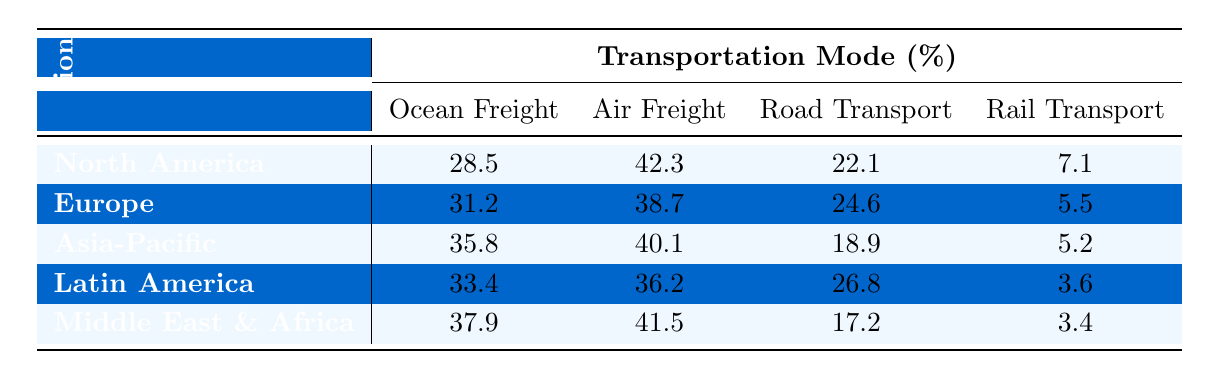What is the highest percentage for Ocean Freight among the regions? By looking at the Ocean Freight percentages for each region, we can see that North America has 28.5, Europe has 31.2, Asia-Pacific has 35.8, Latin America has 33.4, and the Middle East & Africa has 37.9. The highest percentage is 37.9, which is in the Middle East & Africa region.
Answer: 37.9 Which region has the lowest percentage for Road Transport? Checking the Road Transport percentages, North America has 22.1, Europe has 24.6, Asia-Pacific has 18.9, Latin America has 26.8, and the Middle East & Africa has 17.2. The lowest percentage is found in the Middle East & Africa at 17.2.
Answer: 17.2 What is the sum of Air Freight percentages for all regions? Adding the Air Freight percentages from the table gives us: 42.3 (North America) + 38.7 (Europe) + 40.1 (Asia-Pacific) + 36.2 (Latin America) + 41.5 (Middle East & Africa) = 199.
Answer: 199 Is Air Freight the most expensive transportation mode in all regions? Comparing the percentages across all regions, we observe the following: North America (42.3), Europe (38.7), Asia-Pacific (40.1), Latin America (36.2), and Middle East & Africa (41.5). Although Air Freight has high percentages, it's not the highest in Asia-Pacific or Latin America. Hence, the answer is no, it's not the most expensive in all regions.
Answer: No What is the average percentage of Rail Transport across all regions? The percentages for Rail Transport are: 7.1 (North America), 5.5 (Europe), 5.2 (Asia-Pacific), 3.6 (Latin America), and 3.4 (Middle East & Africa). To find the average, we sum these values: 7.1 + 5.5 + 5.2 + 3.6 + 3.4 = 24.8. Then, we divide by the number of regions (5): 24.8 / 5 = 4.96.
Answer: 4.96 Which mode of transportation has the highest percentage in Europe? Looking at the Europe row in the table, we see Ocean Freight at 31.2, Air Freight at 38.7, Road Transport at 24.6, and Rail Transport at 5.5. The highest percentage is for Air Freight at 38.7.
Answer: Air Freight What is the percentage difference between Ocean Freight and Rail Transport in the Asia-Pacific region? In the Asia-Pacific, Ocean Freight is 35.8 and Rail Transport is 5.2. The difference is calculated as 35.8 - 5.2 = 30.6.
Answer: 30.6 In which region is Rail Transport more expensive than in Latin America? For Rail Transport, the percentage is 3.6 in Latin America. The other regions have Rail percentages as follows: 7.1 (North America), 5.5 (Europe), 5.2 (Asia-Pacific), and 3.4 (Middle East & Africa). Only North America has a higher percentage at 7.1, making it the region where Rail Transport is more expensive than Latin America.
Answer: North America What is the trend of Ocean Freight costs from North America to the Middle East & Africa? The Ocean Freight costs for the regions are: North America (28.5), Europe (31.2), Asia-Pacific (35.8), Latin America (33.4), and Middle East & Africa (37.9). The trend shows an upward increase from North America to Middle East & Africa. This suggests that Ocean Freight costs are higher as one moves from North America to Middle East & Africa.
Answer: Increasing trend Which region has the lowest overall logistics cost for Road Transport? The Road Transport percentages across the regions are: North America (22.1), Europe (24.6), Asia-Pacific (18.9), Latin America (26.8), and Middle East & Africa (17.2). The lowest overall cost for Road Transport is in the Middle East & Africa at 17.2.
Answer: Middle East & Africa 